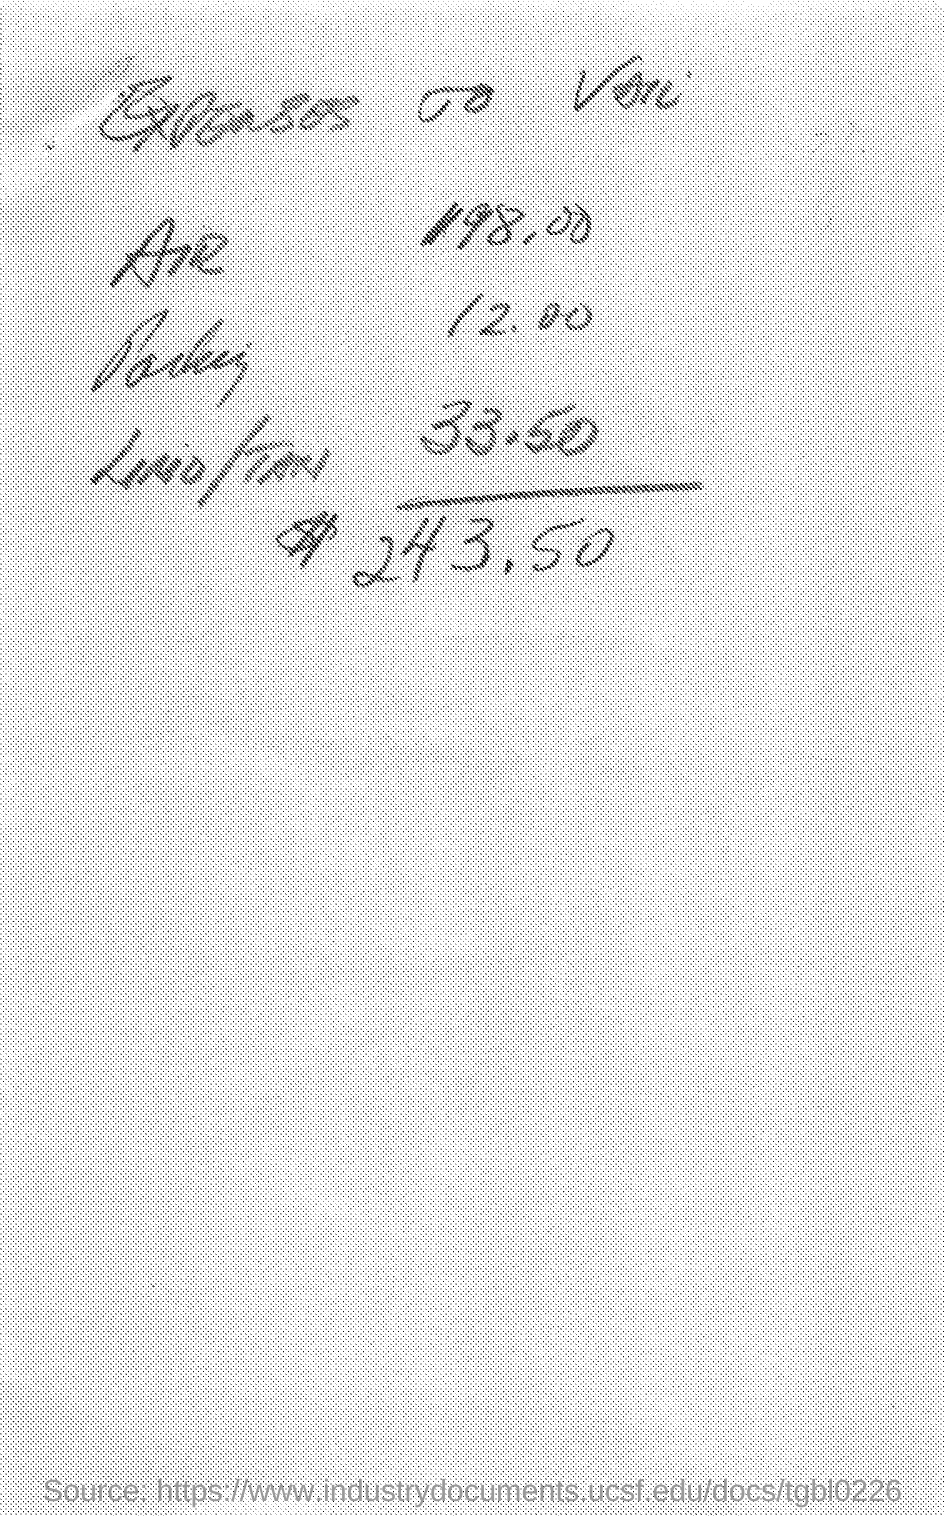Point out several critical features in this image. The expenses for air are 198.00. 